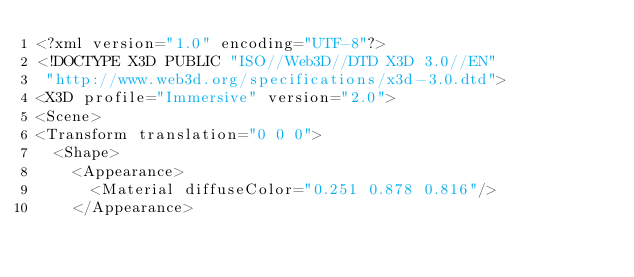<code> <loc_0><loc_0><loc_500><loc_500><_XML_><?xml version="1.0" encoding="UTF-8"?>
<!DOCTYPE X3D PUBLIC "ISO//Web3D//DTD X3D 3.0//EN"
 "http://www.web3d.org/specifications/x3d-3.0.dtd">
<X3D profile="Immersive" version="2.0">
<Scene>
<Transform translation="0 0 0">
  <Shape>
    <Appearance>
      <Material diffuseColor="0.251 0.878 0.816"/>
    </Appearance></code> 